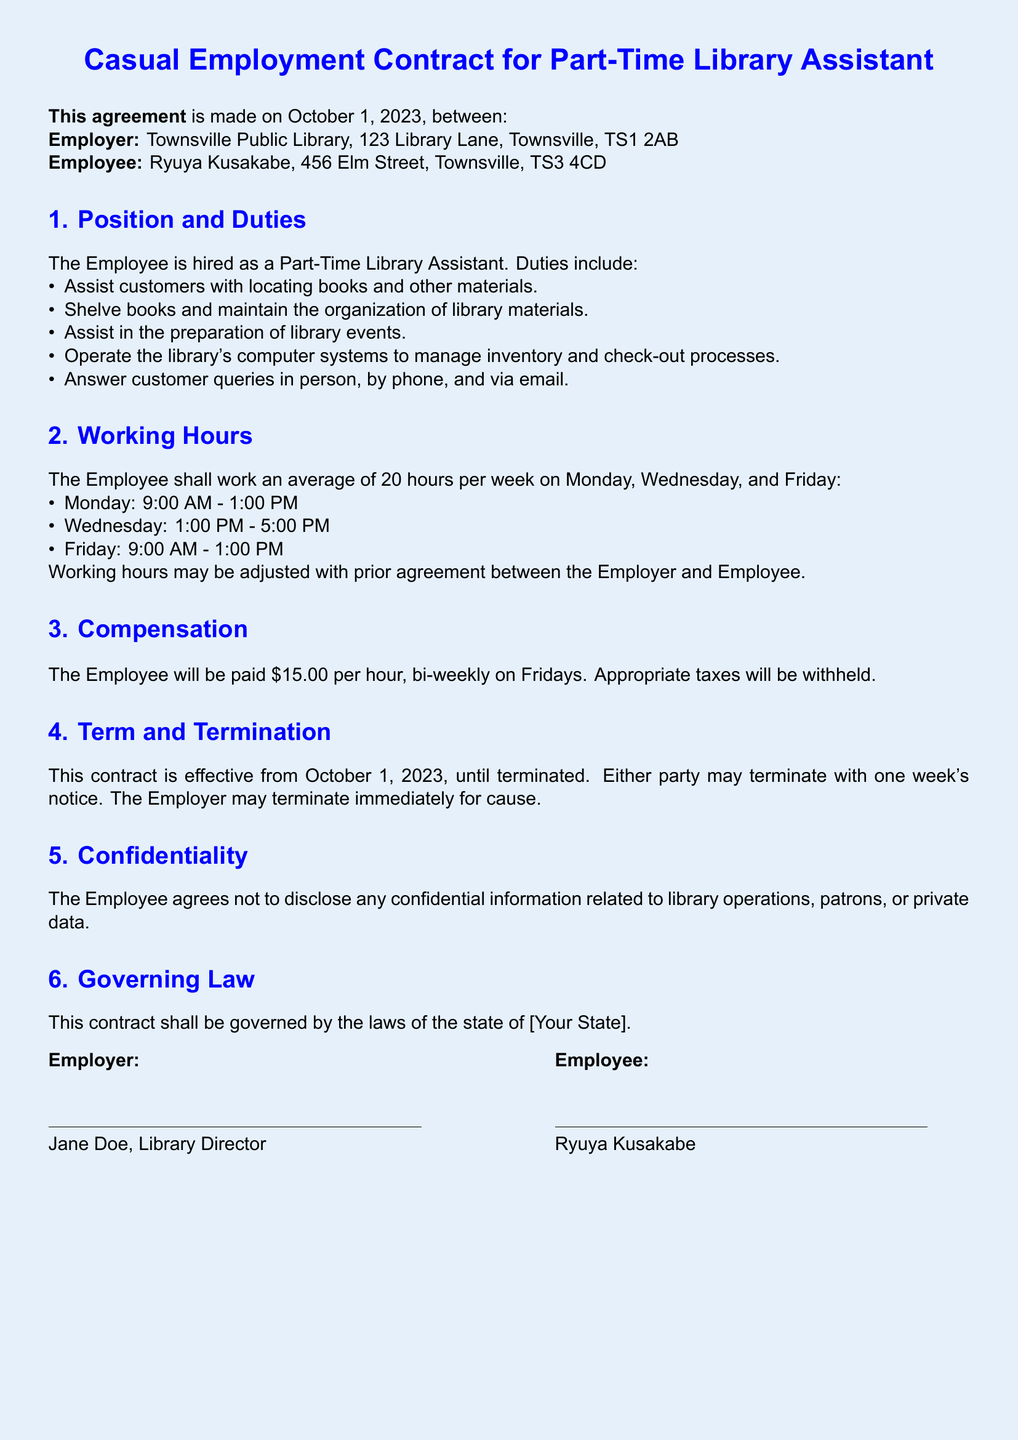What is the position of the employee? The position of the employee is specified in section 1 as Part-Time Library Assistant.
Answer: Part-Time Library Assistant On what date is the contract effective? The effective date of the contract is mentioned at the beginning of the document.
Answer: October 1, 2023 How much is the employee paid per hour? The pay rate is stated in section 3 of the document.
Answer: $15.00 What is the working hour on Wednesday? The working hours for each day are listed in section 2.
Answer: 1:00 PM - 5:00 PM How many hours per week is the employee expected to work? The average working hours are provided in section 2 of the document.
Answer: 20 hours What must the employee do to terminate the contract? The conditions for termination are specified in section 4 of the contract.
Answer: One week's notice Who is the employer? The employer's name is mentioned at the top of the document.
Answer: Townsville Public Library What is required of the employee regarding confidentiality? The confidentiality agreement is found in section 5.
Answer: Not to disclose any confidential information 